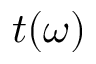<formula> <loc_0><loc_0><loc_500><loc_500>t ( \omega )</formula> 